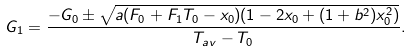Convert formula to latex. <formula><loc_0><loc_0><loc_500><loc_500>G _ { 1 } = \frac { - G _ { 0 } \pm \sqrt { a ( F _ { 0 } + F _ { 1 } T _ { 0 } - x _ { 0 } ) ( 1 - 2 x _ { 0 } + ( 1 + b ^ { 2 } ) x _ { 0 } ^ { 2 } ) } } { T _ { a v } - T _ { 0 } } .</formula> 